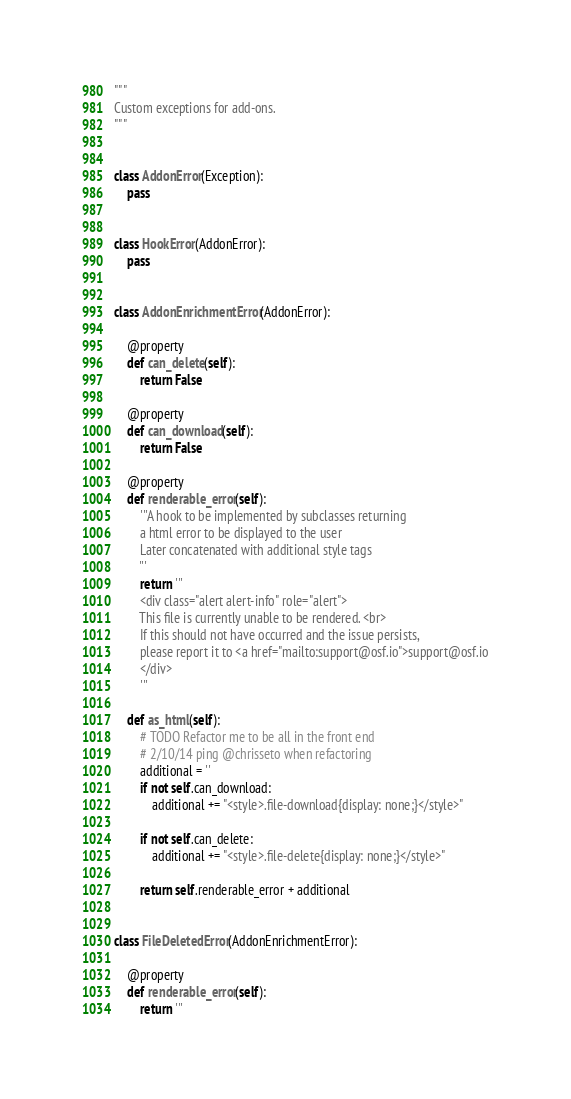Convert code to text. <code><loc_0><loc_0><loc_500><loc_500><_Python_>"""
Custom exceptions for add-ons.
"""


class AddonError(Exception):
    pass


class HookError(AddonError):
    pass


class AddonEnrichmentError(AddonError):

    @property
    def can_delete(self):
        return False

    @property
    def can_download(self):
        return False

    @property
    def renderable_error(self):
        '''A hook to be implemented by subclasses returning
        a html error to be displayed to the user
        Later concatenated with additional style tags
        '''
        return '''
        <div class="alert alert-info" role="alert">
        This file is currently unable to be rendered. <br>
        If this should not have occurred and the issue persists,
        please report it to <a href="mailto:support@osf.io">support@osf.io
        </div>
        '''

    def as_html(self):
        # TODO Refactor me to be all in the front end
        # 2/10/14 ping @chrisseto when refactoring
        additional = ''
        if not self.can_download:
            additional += "<style>.file-download{display: none;}</style>"

        if not self.can_delete:
            additional += "<style>.file-delete{display: none;}</style>"

        return self.renderable_error + additional


class FileDeletedError(AddonEnrichmentError):

    @property
    def renderable_error(self):
        return '''</code> 